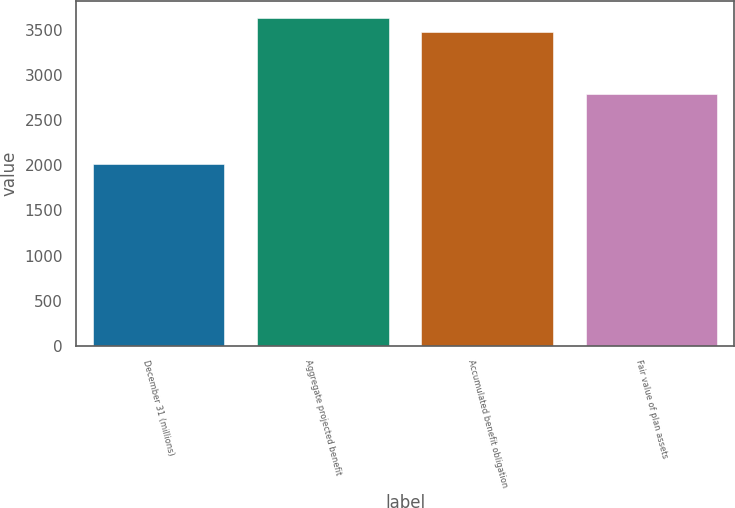Convert chart. <chart><loc_0><loc_0><loc_500><loc_500><bar_chart><fcel>December 31 (millions)<fcel>Aggregate projected benefit<fcel>Accumulated benefit obligation<fcel>Fair value of plan assets<nl><fcel>2017<fcel>3638.02<fcel>3476.1<fcel>2794<nl></chart> 